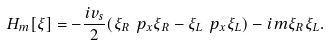Convert formula to latex. <formula><loc_0><loc_0><loc_500><loc_500>H _ { m } [ \xi ] = - \frac { i v _ { s } } { 2 } ( \xi _ { R } \ p _ { x } \xi _ { R } - \xi _ { L } \ p _ { x } \xi _ { L } ) - i m \xi _ { R } \xi _ { L } .</formula> 